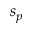<formula> <loc_0><loc_0><loc_500><loc_500>s _ { p }</formula> 